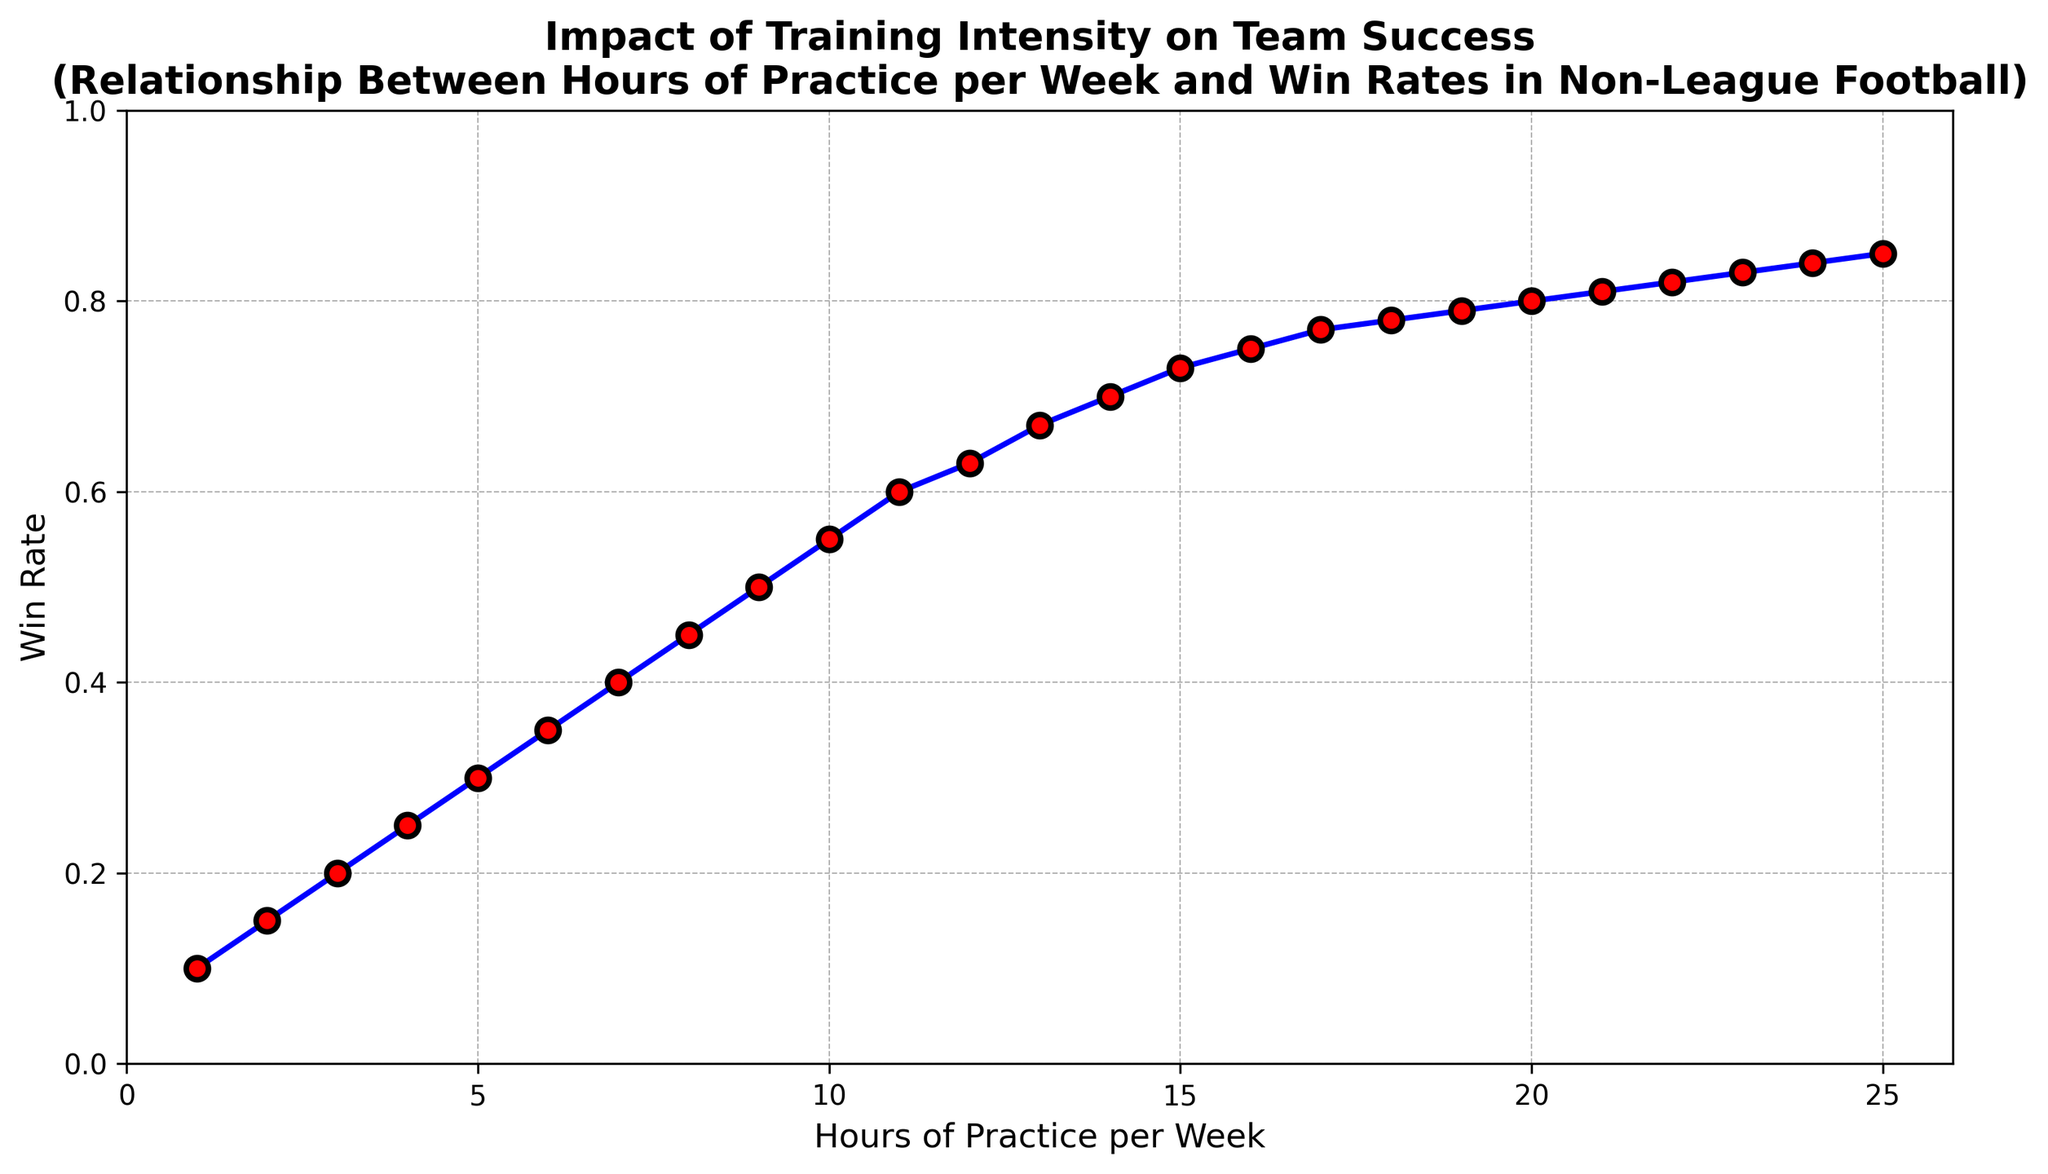What's the win rate when training 10 hours per week? To find the win rate for 10 hours of training per week, look directly at where 'hours_per_week' is 10 on the horizontal axis and check the corresponding point on the vertical axis.
Answer: 0.55 How does the win rate change as training hours increase from 5 to 15 hours per week? Observe the win rate at 5 hours per week (0.3) and at 15 hours per week (0.73), then calculate the difference: 0.73 - 0.3
Answer: 0.43 What is the overall trend in the relationship between training hours and win rate as seen in the plot? The plot shows an upward trend, indicating that as the hours of practice per week increase, the win rate generally increases as well.
Answer: Increasing At what point does the win rate increase the most rapidly? The win rate increases most rapidly in the lower range of training hours, particularly between 1 and 10 hours per week, as evidenced by the steeper slope in this region. More specifically, the initial change from 1 to 10 hours shows larger incremental increases.
Answer: 1-10 hours per week What is the win rate at the highest recorded hours of practice per week? Look at the data point where 'hours_per_week' is 25 and check the corresponding win rate value.
Answer: 0.85 Between which two consecutive training hours is the win rate increase the smallest? Compare the increase in win rate between consecutive hours. Notice that the smallest increase occurs towards the higher range, particularly between 19 to 20 hours per week, where the win rate changes from 0.79 to 0.80.
Answer: 19-20 hours per week How many hours of practice are needed to achieve at least a 75% win rate? Locate where the win rate on the vertical axis first reaches or exceeds 0.75 and find the corresponding 'hours_per_week' value on the horizontal axis. It occurs at 16 hours per week.
Answer: 16 hours per week Does the win rate ever exceed 80%? Check the plot to see if any win rate values go beyond 0.80. The win rate surpasses 80% at 21 hours per week and continues to increase slightly afterwards.
Answer: Yes Compare the increase in win rate from 12 hours to 14 hours of practice per week. For 12 hours of practice, the win rate is 0.63, and for 14 hours, it is 0.70. Calculate the difference: 0.70 - 0.63.
Answer: 0.07 What visual elements are used to emphasize the relationship between training hours and win rates? The plot uses blue lines connecting red markers with black edges and white center points to highlight data points and their trend. Gridlines are also present to help track values.
Answer: Blue lines, red markers, black edges, gridlines 